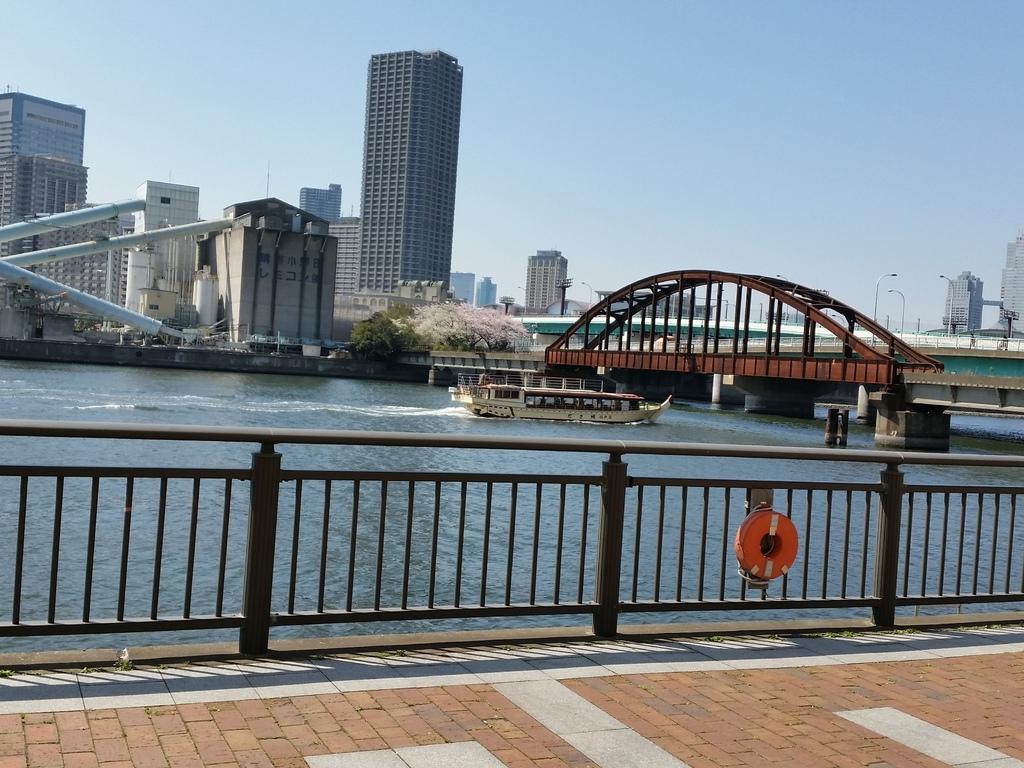Describe this image in one or two sentences. In this image we can see the buildings, trees, light poles and also the bridge. We can also see the boat on the surface of the water. We can see the railing and also the path. In the background we can see the sky. 